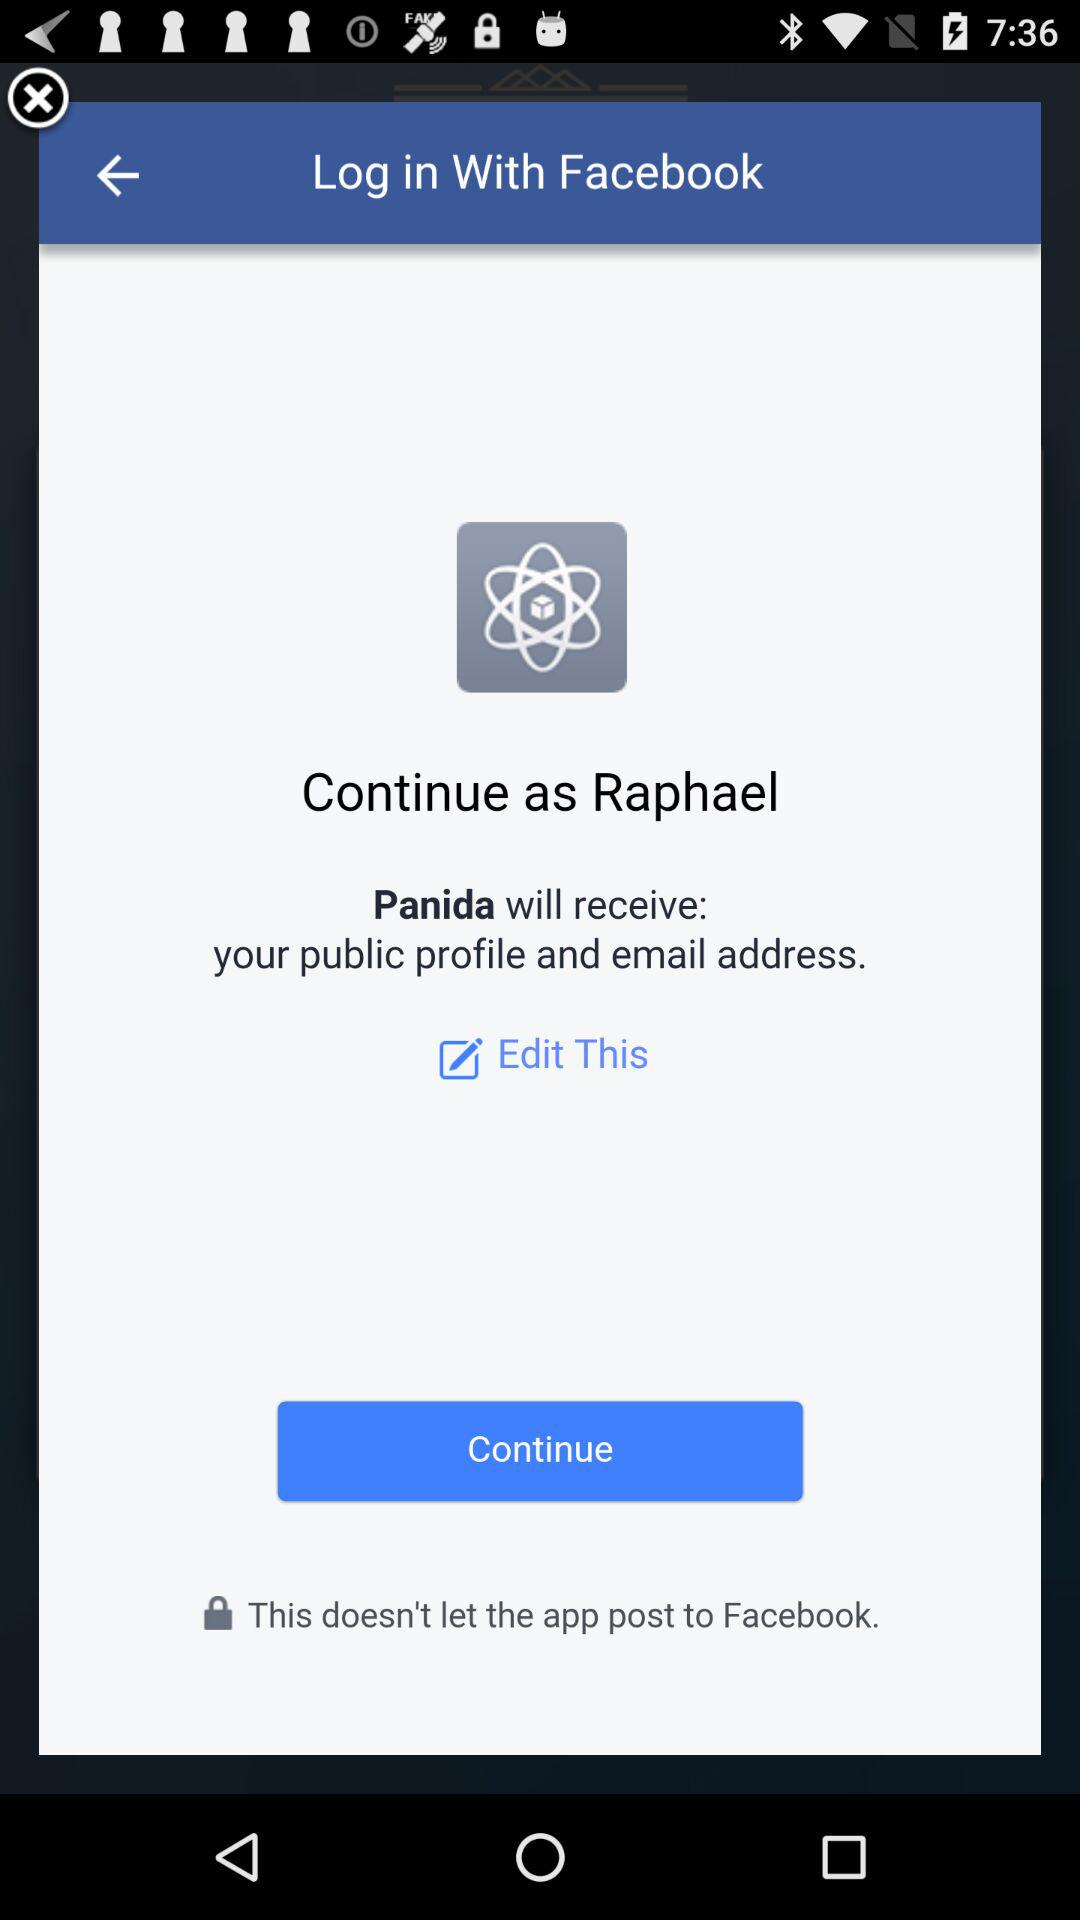What is the login name? The login name is Raphael. 